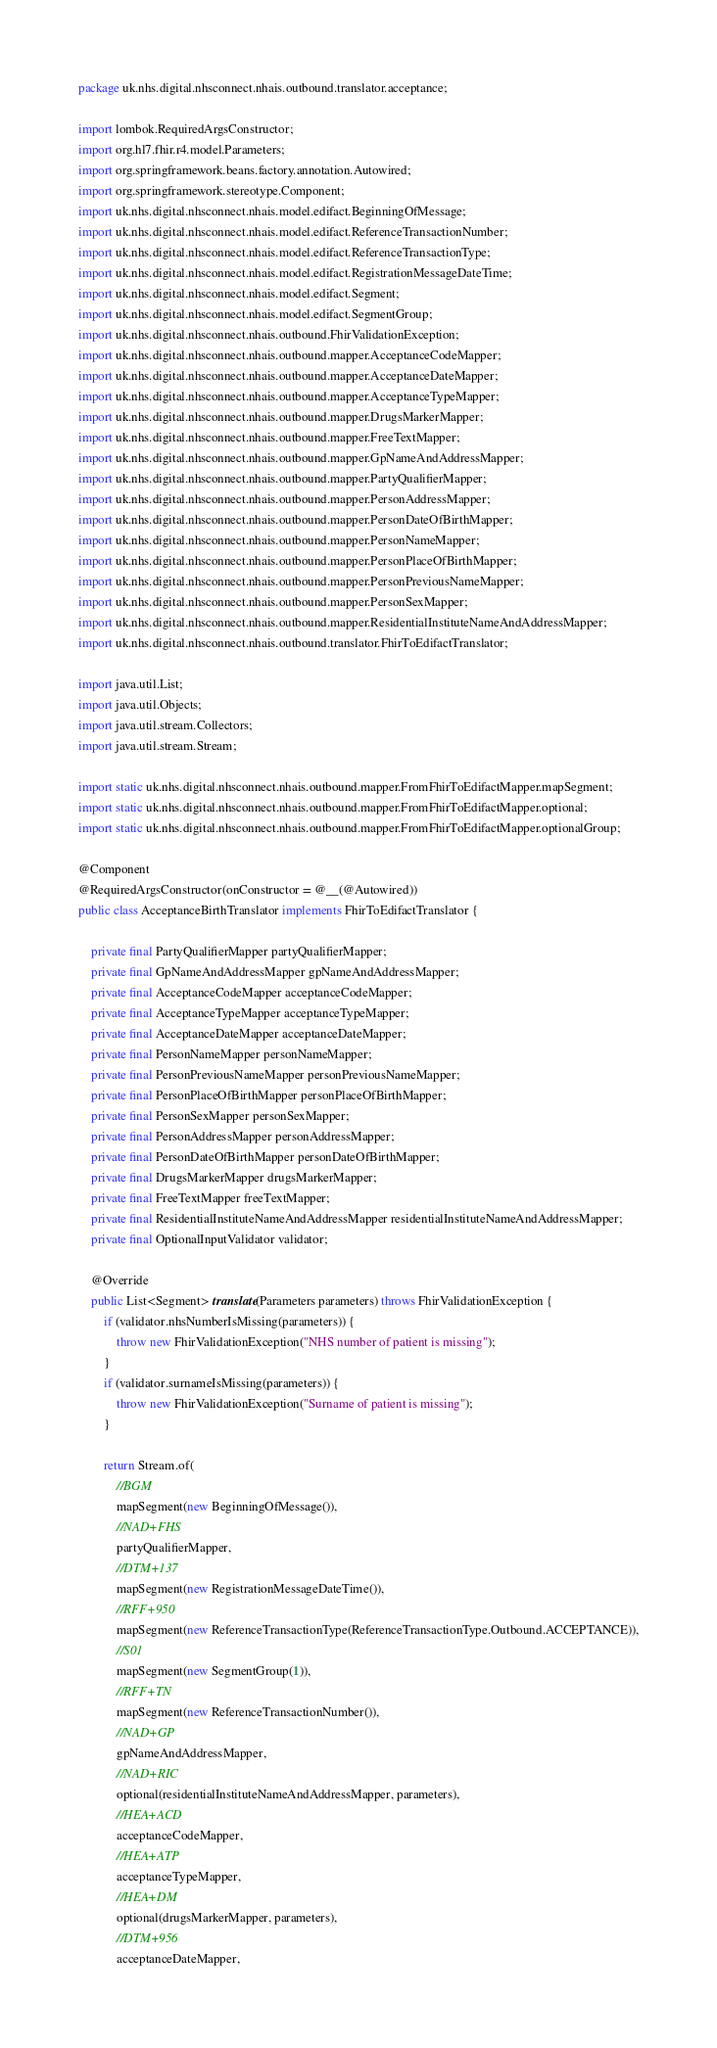<code> <loc_0><loc_0><loc_500><loc_500><_Java_>package uk.nhs.digital.nhsconnect.nhais.outbound.translator.acceptance;

import lombok.RequiredArgsConstructor;
import org.hl7.fhir.r4.model.Parameters;
import org.springframework.beans.factory.annotation.Autowired;
import org.springframework.stereotype.Component;
import uk.nhs.digital.nhsconnect.nhais.model.edifact.BeginningOfMessage;
import uk.nhs.digital.nhsconnect.nhais.model.edifact.ReferenceTransactionNumber;
import uk.nhs.digital.nhsconnect.nhais.model.edifact.ReferenceTransactionType;
import uk.nhs.digital.nhsconnect.nhais.model.edifact.RegistrationMessageDateTime;
import uk.nhs.digital.nhsconnect.nhais.model.edifact.Segment;
import uk.nhs.digital.nhsconnect.nhais.model.edifact.SegmentGroup;
import uk.nhs.digital.nhsconnect.nhais.outbound.FhirValidationException;
import uk.nhs.digital.nhsconnect.nhais.outbound.mapper.AcceptanceCodeMapper;
import uk.nhs.digital.nhsconnect.nhais.outbound.mapper.AcceptanceDateMapper;
import uk.nhs.digital.nhsconnect.nhais.outbound.mapper.AcceptanceTypeMapper;
import uk.nhs.digital.nhsconnect.nhais.outbound.mapper.DrugsMarkerMapper;
import uk.nhs.digital.nhsconnect.nhais.outbound.mapper.FreeTextMapper;
import uk.nhs.digital.nhsconnect.nhais.outbound.mapper.GpNameAndAddressMapper;
import uk.nhs.digital.nhsconnect.nhais.outbound.mapper.PartyQualifierMapper;
import uk.nhs.digital.nhsconnect.nhais.outbound.mapper.PersonAddressMapper;
import uk.nhs.digital.nhsconnect.nhais.outbound.mapper.PersonDateOfBirthMapper;
import uk.nhs.digital.nhsconnect.nhais.outbound.mapper.PersonNameMapper;
import uk.nhs.digital.nhsconnect.nhais.outbound.mapper.PersonPlaceOfBirthMapper;
import uk.nhs.digital.nhsconnect.nhais.outbound.mapper.PersonPreviousNameMapper;
import uk.nhs.digital.nhsconnect.nhais.outbound.mapper.PersonSexMapper;
import uk.nhs.digital.nhsconnect.nhais.outbound.mapper.ResidentialInstituteNameAndAddressMapper;
import uk.nhs.digital.nhsconnect.nhais.outbound.translator.FhirToEdifactTranslator;

import java.util.List;
import java.util.Objects;
import java.util.stream.Collectors;
import java.util.stream.Stream;

import static uk.nhs.digital.nhsconnect.nhais.outbound.mapper.FromFhirToEdifactMapper.mapSegment;
import static uk.nhs.digital.nhsconnect.nhais.outbound.mapper.FromFhirToEdifactMapper.optional;
import static uk.nhs.digital.nhsconnect.nhais.outbound.mapper.FromFhirToEdifactMapper.optionalGroup;

@Component
@RequiredArgsConstructor(onConstructor = @__(@Autowired))
public class AcceptanceBirthTranslator implements FhirToEdifactTranslator {

    private final PartyQualifierMapper partyQualifierMapper;
    private final GpNameAndAddressMapper gpNameAndAddressMapper;
    private final AcceptanceCodeMapper acceptanceCodeMapper;
    private final AcceptanceTypeMapper acceptanceTypeMapper;
    private final AcceptanceDateMapper acceptanceDateMapper;
    private final PersonNameMapper personNameMapper;
    private final PersonPreviousNameMapper personPreviousNameMapper;
    private final PersonPlaceOfBirthMapper personPlaceOfBirthMapper;
    private final PersonSexMapper personSexMapper;
    private final PersonAddressMapper personAddressMapper;
    private final PersonDateOfBirthMapper personDateOfBirthMapper;
    private final DrugsMarkerMapper drugsMarkerMapper;
    private final FreeTextMapper freeTextMapper;
    private final ResidentialInstituteNameAndAddressMapper residentialInstituteNameAndAddressMapper;
    private final OptionalInputValidator validator;

    @Override
    public List<Segment> translate(Parameters parameters) throws FhirValidationException {
        if (validator.nhsNumberIsMissing(parameters)) {
            throw new FhirValidationException("NHS number of patient is missing");
        }
        if (validator.surnameIsMissing(parameters)) {
            throw new FhirValidationException("Surname of patient is missing");
        }

        return Stream.of(
            //BGM
            mapSegment(new BeginningOfMessage()),
            //NAD+FHS
            partyQualifierMapper,
            //DTM+137
            mapSegment(new RegistrationMessageDateTime()),
            //RFF+950
            mapSegment(new ReferenceTransactionType(ReferenceTransactionType.Outbound.ACCEPTANCE)),
            //S01
            mapSegment(new SegmentGroup(1)),
            //RFF+TN
            mapSegment(new ReferenceTransactionNumber()),
            //NAD+GP
            gpNameAndAddressMapper,
            //NAD+RIC
            optional(residentialInstituteNameAndAddressMapper, parameters),
            //HEA+ACD
            acceptanceCodeMapper,
            //HEA+ATP
            acceptanceTypeMapper,
            //HEA+DM
            optional(drugsMarkerMapper, parameters),
            //DTM+956
            acceptanceDateMapper,</code> 